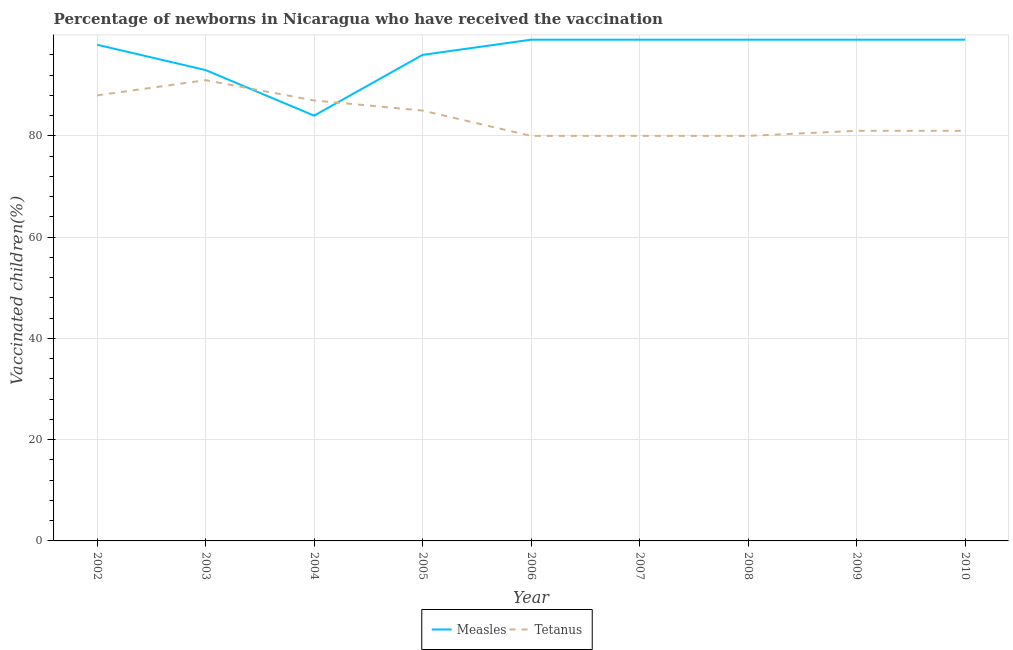What is the percentage of newborns who received vaccination for tetanus in 2007?
Ensure brevity in your answer.  80. Across all years, what is the maximum percentage of newborns who received vaccination for tetanus?
Make the answer very short. 91. Across all years, what is the minimum percentage of newborns who received vaccination for measles?
Ensure brevity in your answer.  84. In which year was the percentage of newborns who received vaccination for measles maximum?
Give a very brief answer. 2006. In which year was the percentage of newborns who received vaccination for tetanus minimum?
Your response must be concise. 2006. What is the total percentage of newborns who received vaccination for measles in the graph?
Provide a succinct answer. 866. What is the difference between the percentage of newborns who received vaccination for measles in 2003 and that in 2005?
Provide a short and direct response. -3. What is the difference between the percentage of newborns who received vaccination for measles in 2004 and the percentage of newborns who received vaccination for tetanus in 2003?
Your answer should be compact. -7. What is the average percentage of newborns who received vaccination for measles per year?
Make the answer very short. 96.22. In the year 2005, what is the difference between the percentage of newborns who received vaccination for tetanus and percentage of newborns who received vaccination for measles?
Your answer should be very brief. -11. In how many years, is the percentage of newborns who received vaccination for tetanus greater than 64 %?
Ensure brevity in your answer.  9. Is the percentage of newborns who received vaccination for tetanus in 2005 less than that in 2009?
Make the answer very short. No. Is the difference between the percentage of newborns who received vaccination for tetanus in 2002 and 2003 greater than the difference between the percentage of newborns who received vaccination for measles in 2002 and 2003?
Your response must be concise. No. What is the difference between the highest and the second highest percentage of newborns who received vaccination for tetanus?
Provide a short and direct response. 3. What is the difference between the highest and the lowest percentage of newborns who received vaccination for measles?
Give a very brief answer. 15. Is the percentage of newborns who received vaccination for tetanus strictly less than the percentage of newborns who received vaccination for measles over the years?
Give a very brief answer. No. How many years are there in the graph?
Ensure brevity in your answer.  9. Does the graph contain any zero values?
Your answer should be compact. No. Where does the legend appear in the graph?
Offer a very short reply. Bottom center. What is the title of the graph?
Give a very brief answer. Percentage of newborns in Nicaragua who have received the vaccination. Does "Revenue" appear as one of the legend labels in the graph?
Keep it short and to the point. No. What is the label or title of the Y-axis?
Your response must be concise. Vaccinated children(%)
. What is the Vaccinated children(%)
 of Tetanus in 2002?
Your answer should be very brief. 88. What is the Vaccinated children(%)
 in Measles in 2003?
Keep it short and to the point. 93. What is the Vaccinated children(%)
 of Tetanus in 2003?
Provide a succinct answer. 91. What is the Vaccinated children(%)
 in Tetanus in 2004?
Your answer should be very brief. 87. What is the Vaccinated children(%)
 of Measles in 2005?
Provide a short and direct response. 96. What is the Vaccinated children(%)
 of Tetanus in 2005?
Ensure brevity in your answer.  85. What is the Vaccinated children(%)
 of Measles in 2007?
Your answer should be compact. 99. What is the Vaccinated children(%)
 of Tetanus in 2007?
Your answer should be compact. 80. Across all years, what is the maximum Vaccinated children(%)
 in Tetanus?
Your answer should be very brief. 91. Across all years, what is the minimum Vaccinated children(%)
 of Measles?
Offer a very short reply. 84. What is the total Vaccinated children(%)
 of Measles in the graph?
Keep it short and to the point. 866. What is the total Vaccinated children(%)
 in Tetanus in the graph?
Your response must be concise. 753. What is the difference between the Vaccinated children(%)
 in Measles in 2002 and that in 2003?
Your response must be concise. 5. What is the difference between the Vaccinated children(%)
 in Measles in 2002 and that in 2006?
Give a very brief answer. -1. What is the difference between the Vaccinated children(%)
 of Tetanus in 2002 and that in 2006?
Provide a succinct answer. 8. What is the difference between the Vaccinated children(%)
 in Measles in 2002 and that in 2007?
Ensure brevity in your answer.  -1. What is the difference between the Vaccinated children(%)
 of Measles in 2002 and that in 2008?
Provide a short and direct response. -1. What is the difference between the Vaccinated children(%)
 in Measles in 2002 and that in 2009?
Provide a succinct answer. -1. What is the difference between the Vaccinated children(%)
 of Tetanus in 2002 and that in 2009?
Keep it short and to the point. 7. What is the difference between the Vaccinated children(%)
 of Measles in 2003 and that in 2006?
Your answer should be very brief. -6. What is the difference between the Vaccinated children(%)
 in Measles in 2003 and that in 2009?
Provide a short and direct response. -6. What is the difference between the Vaccinated children(%)
 of Measles in 2004 and that in 2005?
Keep it short and to the point. -12. What is the difference between the Vaccinated children(%)
 of Measles in 2004 and that in 2007?
Ensure brevity in your answer.  -15. What is the difference between the Vaccinated children(%)
 of Measles in 2004 and that in 2009?
Ensure brevity in your answer.  -15. What is the difference between the Vaccinated children(%)
 in Tetanus in 2004 and that in 2009?
Your answer should be compact. 6. What is the difference between the Vaccinated children(%)
 in Measles in 2005 and that in 2008?
Keep it short and to the point. -3. What is the difference between the Vaccinated children(%)
 in Measles in 2005 and that in 2009?
Offer a very short reply. -3. What is the difference between the Vaccinated children(%)
 in Tetanus in 2005 and that in 2009?
Ensure brevity in your answer.  4. What is the difference between the Vaccinated children(%)
 in Tetanus in 2005 and that in 2010?
Ensure brevity in your answer.  4. What is the difference between the Vaccinated children(%)
 in Measles in 2006 and that in 2007?
Your response must be concise. 0. What is the difference between the Vaccinated children(%)
 of Tetanus in 2006 and that in 2007?
Your response must be concise. 0. What is the difference between the Vaccinated children(%)
 in Tetanus in 2006 and that in 2009?
Give a very brief answer. -1. What is the difference between the Vaccinated children(%)
 of Measles in 2007 and that in 2009?
Your answer should be very brief. 0. What is the difference between the Vaccinated children(%)
 in Tetanus in 2007 and that in 2009?
Your answer should be compact. -1. What is the difference between the Vaccinated children(%)
 in Tetanus in 2007 and that in 2010?
Your response must be concise. -1. What is the difference between the Vaccinated children(%)
 in Measles in 2008 and that in 2009?
Provide a short and direct response. 0. What is the difference between the Vaccinated children(%)
 of Tetanus in 2008 and that in 2009?
Your answer should be compact. -1. What is the difference between the Vaccinated children(%)
 of Tetanus in 2009 and that in 2010?
Offer a terse response. 0. What is the difference between the Vaccinated children(%)
 in Measles in 2002 and the Vaccinated children(%)
 in Tetanus in 2004?
Your answer should be compact. 11. What is the difference between the Vaccinated children(%)
 in Measles in 2002 and the Vaccinated children(%)
 in Tetanus in 2005?
Ensure brevity in your answer.  13. What is the difference between the Vaccinated children(%)
 in Measles in 2002 and the Vaccinated children(%)
 in Tetanus in 2006?
Your answer should be compact. 18. What is the difference between the Vaccinated children(%)
 of Measles in 2002 and the Vaccinated children(%)
 of Tetanus in 2007?
Provide a succinct answer. 18. What is the difference between the Vaccinated children(%)
 of Measles in 2002 and the Vaccinated children(%)
 of Tetanus in 2008?
Give a very brief answer. 18. What is the difference between the Vaccinated children(%)
 in Measles in 2003 and the Vaccinated children(%)
 in Tetanus in 2004?
Make the answer very short. 6. What is the difference between the Vaccinated children(%)
 in Measles in 2003 and the Vaccinated children(%)
 in Tetanus in 2005?
Your response must be concise. 8. What is the difference between the Vaccinated children(%)
 in Measles in 2003 and the Vaccinated children(%)
 in Tetanus in 2006?
Provide a short and direct response. 13. What is the difference between the Vaccinated children(%)
 of Measles in 2003 and the Vaccinated children(%)
 of Tetanus in 2007?
Offer a terse response. 13. What is the difference between the Vaccinated children(%)
 in Measles in 2003 and the Vaccinated children(%)
 in Tetanus in 2008?
Offer a terse response. 13. What is the difference between the Vaccinated children(%)
 in Measles in 2003 and the Vaccinated children(%)
 in Tetanus in 2010?
Keep it short and to the point. 12. What is the difference between the Vaccinated children(%)
 of Measles in 2004 and the Vaccinated children(%)
 of Tetanus in 2005?
Keep it short and to the point. -1. What is the difference between the Vaccinated children(%)
 in Measles in 2004 and the Vaccinated children(%)
 in Tetanus in 2006?
Offer a terse response. 4. What is the difference between the Vaccinated children(%)
 in Measles in 2004 and the Vaccinated children(%)
 in Tetanus in 2010?
Make the answer very short. 3. What is the difference between the Vaccinated children(%)
 in Measles in 2005 and the Vaccinated children(%)
 in Tetanus in 2006?
Your response must be concise. 16. What is the difference between the Vaccinated children(%)
 in Measles in 2005 and the Vaccinated children(%)
 in Tetanus in 2008?
Make the answer very short. 16. What is the difference between the Vaccinated children(%)
 of Measles in 2005 and the Vaccinated children(%)
 of Tetanus in 2009?
Give a very brief answer. 15. What is the difference between the Vaccinated children(%)
 of Measles in 2005 and the Vaccinated children(%)
 of Tetanus in 2010?
Provide a succinct answer. 15. What is the difference between the Vaccinated children(%)
 of Measles in 2006 and the Vaccinated children(%)
 of Tetanus in 2008?
Offer a terse response. 19. What is the difference between the Vaccinated children(%)
 of Measles in 2006 and the Vaccinated children(%)
 of Tetanus in 2010?
Your response must be concise. 18. What is the difference between the Vaccinated children(%)
 in Measles in 2007 and the Vaccinated children(%)
 in Tetanus in 2008?
Give a very brief answer. 19. What is the difference between the Vaccinated children(%)
 in Measles in 2008 and the Vaccinated children(%)
 in Tetanus in 2010?
Provide a succinct answer. 18. What is the average Vaccinated children(%)
 of Measles per year?
Your answer should be compact. 96.22. What is the average Vaccinated children(%)
 in Tetanus per year?
Your response must be concise. 83.67. In the year 2008, what is the difference between the Vaccinated children(%)
 of Measles and Vaccinated children(%)
 of Tetanus?
Keep it short and to the point. 19. In the year 2010, what is the difference between the Vaccinated children(%)
 of Measles and Vaccinated children(%)
 of Tetanus?
Your answer should be compact. 18. What is the ratio of the Vaccinated children(%)
 in Measles in 2002 to that in 2003?
Offer a very short reply. 1.05. What is the ratio of the Vaccinated children(%)
 of Tetanus in 2002 to that in 2004?
Keep it short and to the point. 1.01. What is the ratio of the Vaccinated children(%)
 of Measles in 2002 to that in 2005?
Provide a succinct answer. 1.02. What is the ratio of the Vaccinated children(%)
 in Tetanus in 2002 to that in 2005?
Keep it short and to the point. 1.04. What is the ratio of the Vaccinated children(%)
 in Tetanus in 2002 to that in 2006?
Ensure brevity in your answer.  1.1. What is the ratio of the Vaccinated children(%)
 of Measles in 2002 to that in 2007?
Give a very brief answer. 0.99. What is the ratio of the Vaccinated children(%)
 of Measles in 2002 to that in 2008?
Provide a succinct answer. 0.99. What is the ratio of the Vaccinated children(%)
 of Measles in 2002 to that in 2009?
Keep it short and to the point. 0.99. What is the ratio of the Vaccinated children(%)
 of Tetanus in 2002 to that in 2009?
Keep it short and to the point. 1.09. What is the ratio of the Vaccinated children(%)
 in Tetanus in 2002 to that in 2010?
Keep it short and to the point. 1.09. What is the ratio of the Vaccinated children(%)
 in Measles in 2003 to that in 2004?
Ensure brevity in your answer.  1.11. What is the ratio of the Vaccinated children(%)
 of Tetanus in 2003 to that in 2004?
Provide a succinct answer. 1.05. What is the ratio of the Vaccinated children(%)
 in Measles in 2003 to that in 2005?
Keep it short and to the point. 0.97. What is the ratio of the Vaccinated children(%)
 of Tetanus in 2003 to that in 2005?
Your answer should be very brief. 1.07. What is the ratio of the Vaccinated children(%)
 of Measles in 2003 to that in 2006?
Offer a very short reply. 0.94. What is the ratio of the Vaccinated children(%)
 of Tetanus in 2003 to that in 2006?
Your answer should be very brief. 1.14. What is the ratio of the Vaccinated children(%)
 in Measles in 2003 to that in 2007?
Offer a terse response. 0.94. What is the ratio of the Vaccinated children(%)
 in Tetanus in 2003 to that in 2007?
Offer a very short reply. 1.14. What is the ratio of the Vaccinated children(%)
 in Measles in 2003 to that in 2008?
Your answer should be compact. 0.94. What is the ratio of the Vaccinated children(%)
 of Tetanus in 2003 to that in 2008?
Your response must be concise. 1.14. What is the ratio of the Vaccinated children(%)
 of Measles in 2003 to that in 2009?
Your answer should be very brief. 0.94. What is the ratio of the Vaccinated children(%)
 in Tetanus in 2003 to that in 2009?
Offer a terse response. 1.12. What is the ratio of the Vaccinated children(%)
 of Measles in 2003 to that in 2010?
Your response must be concise. 0.94. What is the ratio of the Vaccinated children(%)
 in Tetanus in 2003 to that in 2010?
Your answer should be compact. 1.12. What is the ratio of the Vaccinated children(%)
 of Measles in 2004 to that in 2005?
Provide a short and direct response. 0.88. What is the ratio of the Vaccinated children(%)
 in Tetanus in 2004 to that in 2005?
Offer a very short reply. 1.02. What is the ratio of the Vaccinated children(%)
 in Measles in 2004 to that in 2006?
Provide a short and direct response. 0.85. What is the ratio of the Vaccinated children(%)
 in Tetanus in 2004 to that in 2006?
Provide a short and direct response. 1.09. What is the ratio of the Vaccinated children(%)
 of Measles in 2004 to that in 2007?
Ensure brevity in your answer.  0.85. What is the ratio of the Vaccinated children(%)
 in Tetanus in 2004 to that in 2007?
Provide a succinct answer. 1.09. What is the ratio of the Vaccinated children(%)
 of Measles in 2004 to that in 2008?
Give a very brief answer. 0.85. What is the ratio of the Vaccinated children(%)
 of Tetanus in 2004 to that in 2008?
Your answer should be compact. 1.09. What is the ratio of the Vaccinated children(%)
 of Measles in 2004 to that in 2009?
Keep it short and to the point. 0.85. What is the ratio of the Vaccinated children(%)
 in Tetanus in 2004 to that in 2009?
Keep it short and to the point. 1.07. What is the ratio of the Vaccinated children(%)
 in Measles in 2004 to that in 2010?
Ensure brevity in your answer.  0.85. What is the ratio of the Vaccinated children(%)
 in Tetanus in 2004 to that in 2010?
Provide a short and direct response. 1.07. What is the ratio of the Vaccinated children(%)
 in Measles in 2005 to that in 2006?
Offer a very short reply. 0.97. What is the ratio of the Vaccinated children(%)
 in Tetanus in 2005 to that in 2006?
Make the answer very short. 1.06. What is the ratio of the Vaccinated children(%)
 of Measles in 2005 to that in 2007?
Ensure brevity in your answer.  0.97. What is the ratio of the Vaccinated children(%)
 in Measles in 2005 to that in 2008?
Provide a short and direct response. 0.97. What is the ratio of the Vaccinated children(%)
 of Tetanus in 2005 to that in 2008?
Ensure brevity in your answer.  1.06. What is the ratio of the Vaccinated children(%)
 in Measles in 2005 to that in 2009?
Keep it short and to the point. 0.97. What is the ratio of the Vaccinated children(%)
 in Tetanus in 2005 to that in 2009?
Your response must be concise. 1.05. What is the ratio of the Vaccinated children(%)
 of Measles in 2005 to that in 2010?
Provide a succinct answer. 0.97. What is the ratio of the Vaccinated children(%)
 of Tetanus in 2005 to that in 2010?
Your answer should be very brief. 1.05. What is the ratio of the Vaccinated children(%)
 in Measles in 2006 to that in 2007?
Ensure brevity in your answer.  1. What is the ratio of the Vaccinated children(%)
 of Tetanus in 2006 to that in 2007?
Give a very brief answer. 1. What is the ratio of the Vaccinated children(%)
 of Measles in 2006 to that in 2008?
Your answer should be compact. 1. What is the ratio of the Vaccinated children(%)
 of Measles in 2006 to that in 2009?
Offer a terse response. 1. What is the ratio of the Vaccinated children(%)
 of Tetanus in 2006 to that in 2009?
Your response must be concise. 0.99. What is the ratio of the Vaccinated children(%)
 in Tetanus in 2007 to that in 2008?
Keep it short and to the point. 1. What is the ratio of the Vaccinated children(%)
 in Measles in 2007 to that in 2009?
Give a very brief answer. 1. What is the ratio of the Vaccinated children(%)
 of Tetanus in 2007 to that in 2009?
Your answer should be compact. 0.99. What is the ratio of the Vaccinated children(%)
 in Measles in 2007 to that in 2010?
Offer a terse response. 1. What is the ratio of the Vaccinated children(%)
 in Tetanus in 2007 to that in 2010?
Ensure brevity in your answer.  0.99. What is the ratio of the Vaccinated children(%)
 of Tetanus in 2008 to that in 2010?
Offer a very short reply. 0.99. What is the ratio of the Vaccinated children(%)
 in Measles in 2009 to that in 2010?
Provide a short and direct response. 1. What is the ratio of the Vaccinated children(%)
 in Tetanus in 2009 to that in 2010?
Provide a succinct answer. 1. What is the difference between the highest and the second highest Vaccinated children(%)
 of Tetanus?
Your response must be concise. 3. What is the difference between the highest and the lowest Vaccinated children(%)
 in Measles?
Your response must be concise. 15. What is the difference between the highest and the lowest Vaccinated children(%)
 of Tetanus?
Provide a short and direct response. 11. 